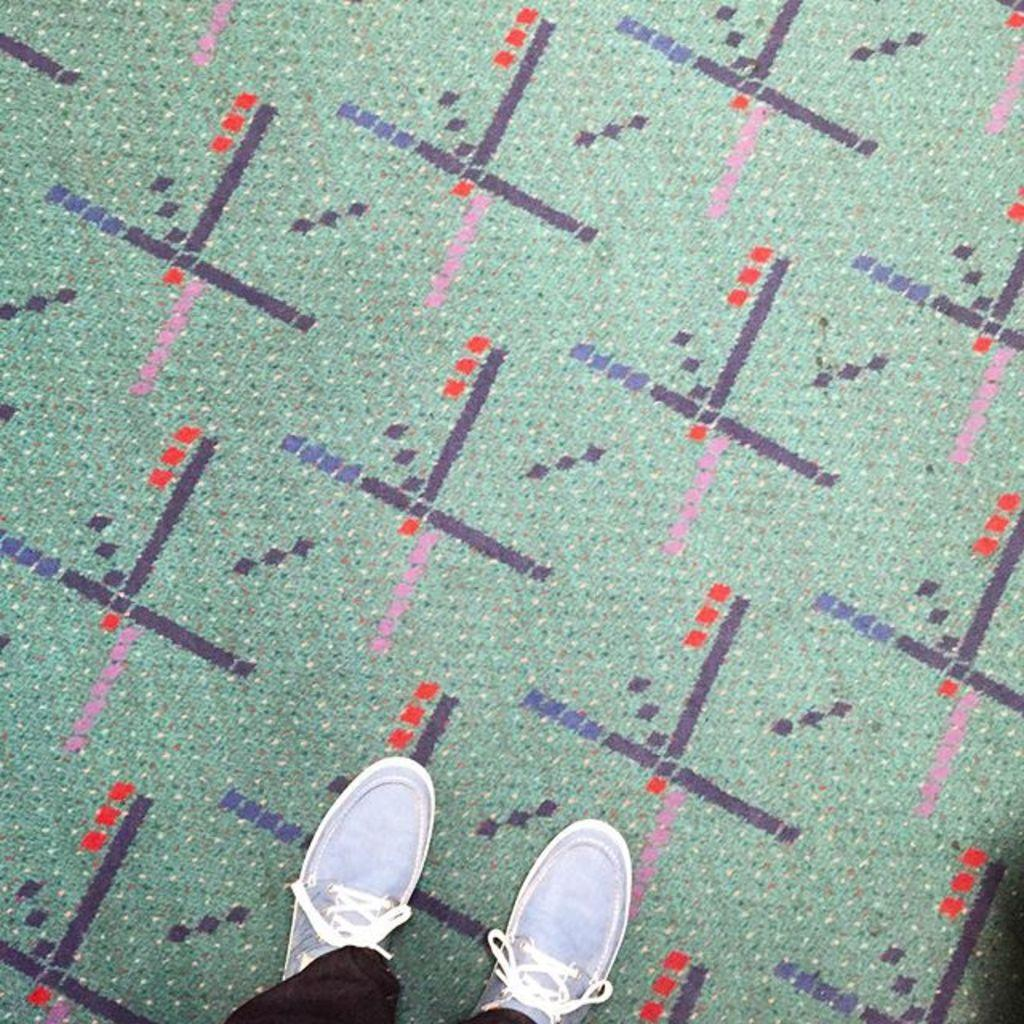What is the main subject of the image? The main subject of the image is a person standing at the bottom. What can be observed about the person's shoes? The person is wearing blue shoes. What is the color of the floor mat in the image? The floor mat is in green color. How many cherries are on the person's head in the image? There are no cherries present on the person's head in the image. What type of prose is being recited by the person in the image? There is no indication of any prose or recitation in the image. 